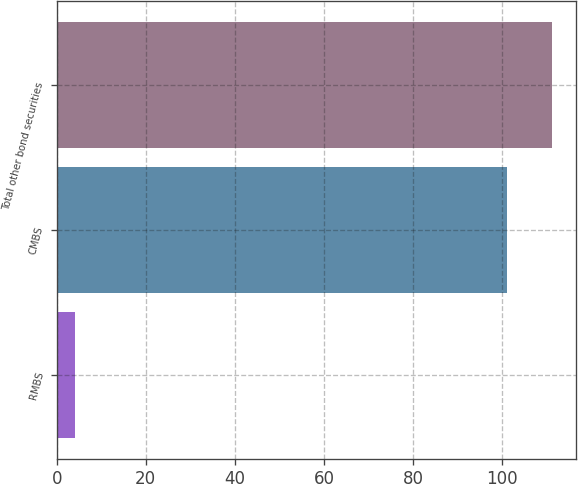<chart> <loc_0><loc_0><loc_500><loc_500><bar_chart><fcel>RMBS<fcel>CMBS<fcel>Total other bond securities<nl><fcel>4<fcel>101<fcel>111.1<nl></chart> 